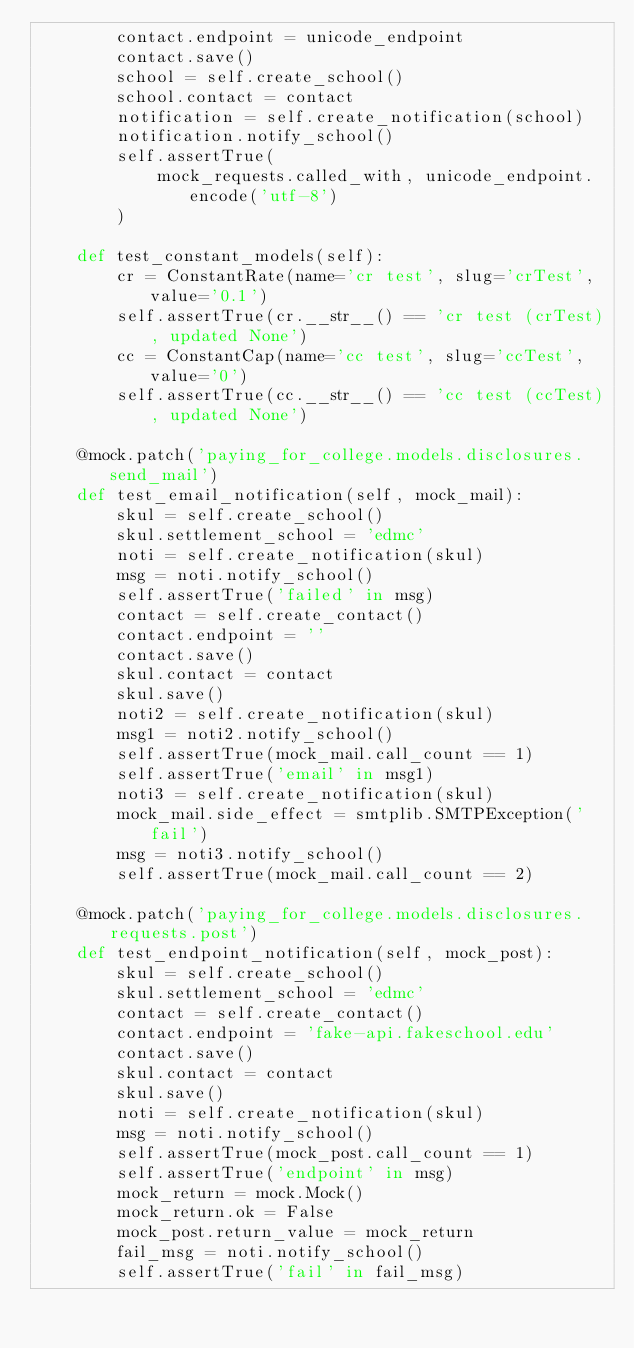Convert code to text. <code><loc_0><loc_0><loc_500><loc_500><_Python_>        contact.endpoint = unicode_endpoint
        contact.save()
        school = self.create_school()
        school.contact = contact
        notification = self.create_notification(school)
        notification.notify_school()
        self.assertTrue(
            mock_requests.called_with, unicode_endpoint.encode('utf-8')
        )

    def test_constant_models(self):
        cr = ConstantRate(name='cr test', slug='crTest', value='0.1')
        self.assertTrue(cr.__str__() == 'cr test (crTest), updated None')
        cc = ConstantCap(name='cc test', slug='ccTest', value='0')
        self.assertTrue(cc.__str__() == 'cc test (ccTest), updated None')

    @mock.patch('paying_for_college.models.disclosures.send_mail')
    def test_email_notification(self, mock_mail):
        skul = self.create_school()
        skul.settlement_school = 'edmc'
        noti = self.create_notification(skul)
        msg = noti.notify_school()
        self.assertTrue('failed' in msg)
        contact = self.create_contact()
        contact.endpoint = ''
        contact.save()
        skul.contact = contact
        skul.save()
        noti2 = self.create_notification(skul)
        msg1 = noti2.notify_school()
        self.assertTrue(mock_mail.call_count == 1)
        self.assertTrue('email' in msg1)
        noti3 = self.create_notification(skul)
        mock_mail.side_effect = smtplib.SMTPException('fail')
        msg = noti3.notify_school()
        self.assertTrue(mock_mail.call_count == 2)

    @mock.patch('paying_for_college.models.disclosures.requests.post')
    def test_endpoint_notification(self, mock_post):
        skul = self.create_school()
        skul.settlement_school = 'edmc'
        contact = self.create_contact()
        contact.endpoint = 'fake-api.fakeschool.edu'
        contact.save()
        skul.contact = contact
        skul.save()
        noti = self.create_notification(skul)
        msg = noti.notify_school()
        self.assertTrue(mock_post.call_count == 1)
        self.assertTrue('endpoint' in msg)
        mock_return = mock.Mock()
        mock_return.ok = False
        mock_post.return_value = mock_return
        fail_msg = noti.notify_school()
        self.assertTrue('fail' in fail_msg)
</code> 